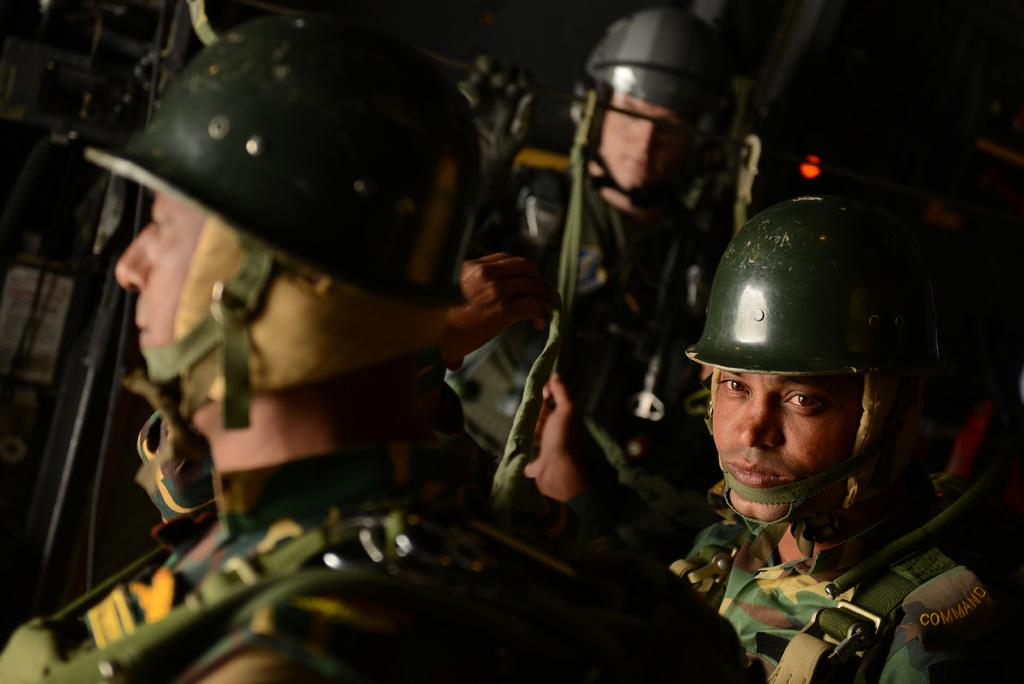How many people are in the image? There are three people standing in the image. What are the people wearing on their heads? The people are wearing helmets. What is the color of the helmets? The helmets are dark green in color. Can you describe any other objects in the image that are black? There is a black color object in the image, possibly referring to the helmets or another object. What type of sofa can be seen in the image? There is no sofa present in the image. Is the team wearing matching uniforms in the image? The provided facts do not mention a team or uniforms, so we cannot determine if they are wearing matching uniforms. 